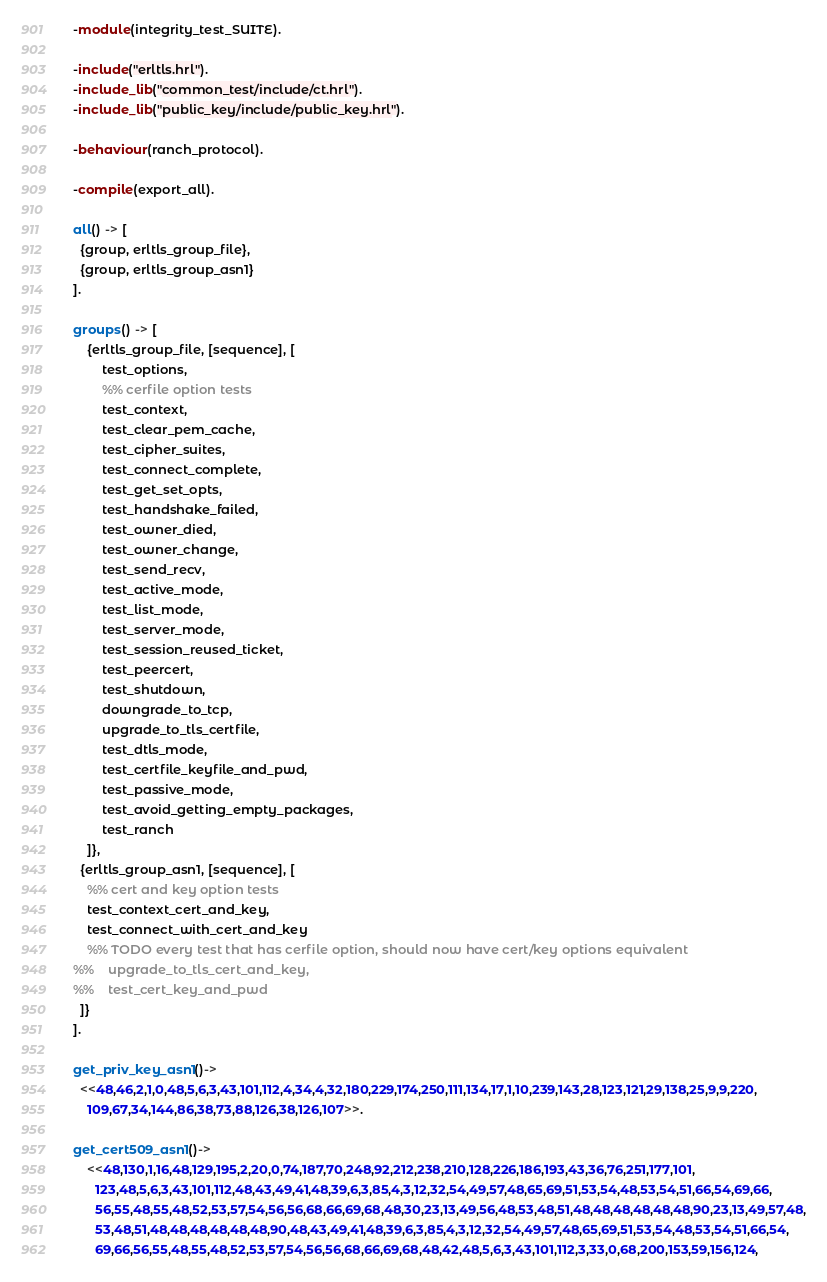Convert code to text. <code><loc_0><loc_0><loc_500><loc_500><_Erlang_>-module(integrity_test_SUITE).

-include("erltls.hrl").
-include_lib("common_test/include/ct.hrl").
-include_lib("public_key/include/public_key.hrl").

-behaviour(ranch_protocol).

-compile(export_all).

all() -> [
  {group, erltls_group_file},
  {group, erltls_group_asn1}
].

groups() -> [
    {erltls_group_file, [sequence], [
        test_options,
        %% cerfile option tests
        test_context,
        test_clear_pem_cache,
        test_cipher_suites,
        test_connect_complete,
        test_get_set_opts,
        test_handshake_failed,
        test_owner_died,
        test_owner_change,
        test_send_recv,
        test_active_mode,
        test_list_mode,
        test_server_mode,
        test_session_reused_ticket,
        test_peercert,
        test_shutdown,
        downgrade_to_tcp,
        upgrade_to_tls_certfile,
        test_dtls_mode,
        test_certfile_keyfile_and_pwd,
        test_passive_mode,
        test_avoid_getting_empty_packages,
        test_ranch
    ]},
  {erltls_group_asn1, [sequence], [
    %% cert and key option tests
    test_context_cert_and_key,
    test_connect_with_cert_and_key
    %% TODO every test that has cerfile option, should now have cert/key options equivalent
%%    upgrade_to_tls_cert_and_key,
%%    test_cert_key_and_pwd
  ]}
].

get_priv_key_asn1()->
  <<48,46,2,1,0,48,5,6,3,43,101,112,4,34,4,32,180,229,174,250,111,134,17,1,10,239,143,28,123,121,29,138,25,9,9,220,
    109,67,34,144,86,38,73,88,126,38,126,107>>.

get_cert509_asn1()->
    <<48,130,1,16,48,129,195,2,20,0,74,187,70,248,92,212,238,210,128,226,186,193,43,36,76,251,177,101,
      123,48,5,6,3,43,101,112,48,43,49,41,48,39,6,3,85,4,3,12,32,54,49,57,48,65,69,51,53,54,48,53,54,51,66,54,69,66,
      56,55,48,55,48,52,53,57,54,56,56,68,66,69,68,48,30,23,13,49,56,48,53,48,51,48,48,48,48,48,48,90,23,13,49,57,48,
      53,48,51,48,48,48,48,48,48,90,48,43,49,41,48,39,6,3,85,4,3,12,32,54,49,57,48,65,69,51,53,54,48,53,54,51,66,54,
      69,66,56,55,48,55,48,52,53,57,54,56,56,68,66,69,68,48,42,48,5,6,3,43,101,112,3,33,0,68,200,153,59,156,124,</code> 